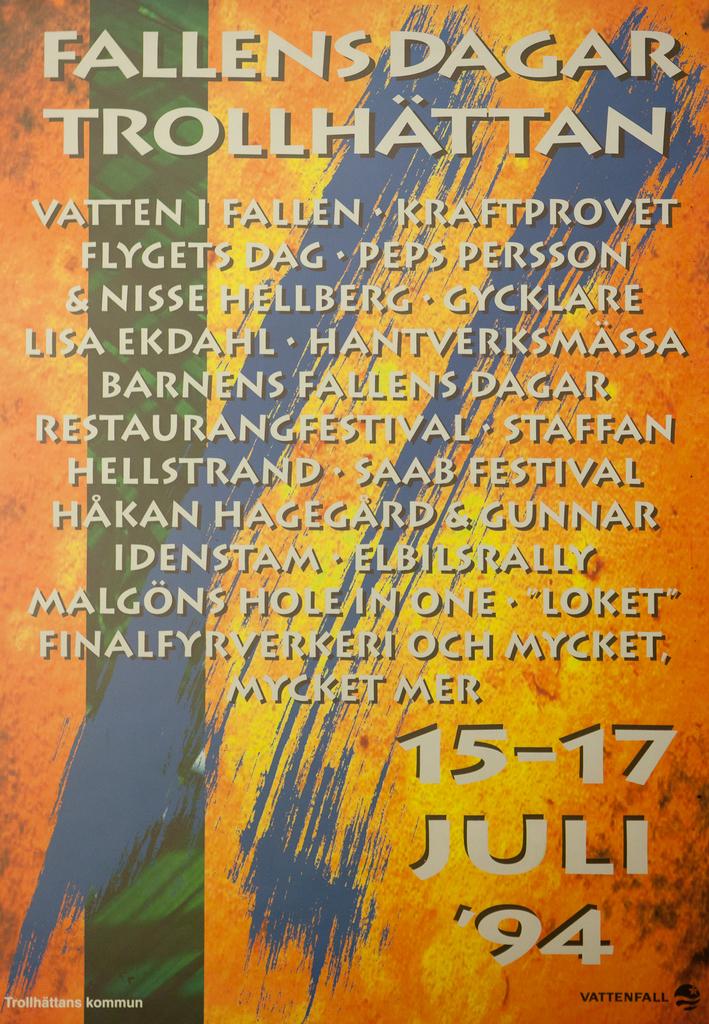When will ,"fallen dagar" be touring?
Give a very brief answer. 15-17 july 1994. What year is listed on the poster?
Make the answer very short. 1994. 